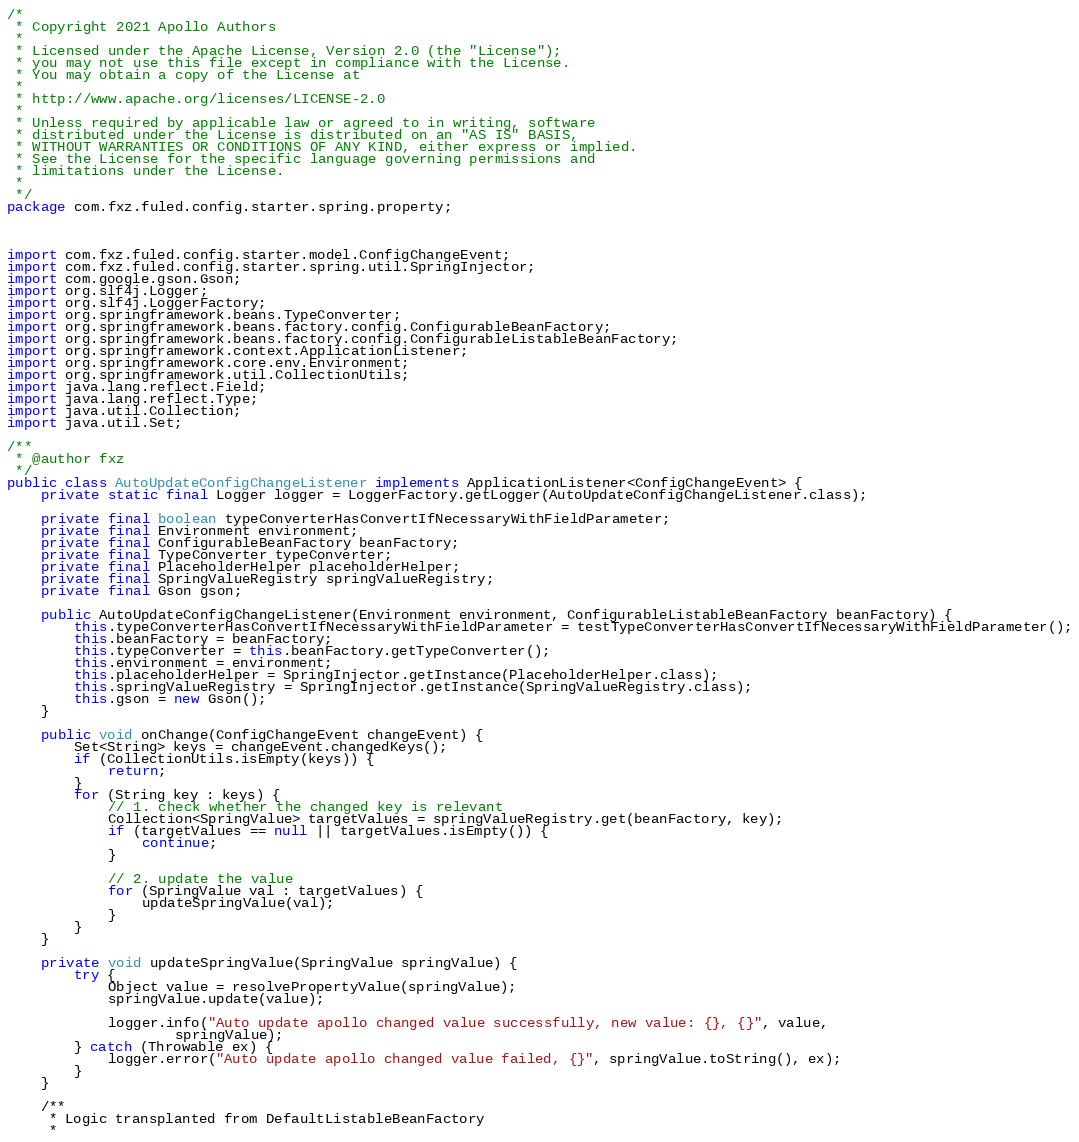<code> <loc_0><loc_0><loc_500><loc_500><_Java_>/*
 * Copyright 2021 Apollo Authors
 *
 * Licensed under the Apache License, Version 2.0 (the "License");
 * you may not use this file except in compliance with the License.
 * You may obtain a copy of the License at
 *
 * http://www.apache.org/licenses/LICENSE-2.0
 *
 * Unless required by applicable law or agreed to in writing, software
 * distributed under the License is distributed on an "AS IS" BASIS,
 * WITHOUT WARRANTIES OR CONDITIONS OF ANY KIND, either express or implied.
 * See the License for the specific language governing permissions and
 * limitations under the License.
 *
 */
package com.fxz.fuled.config.starter.spring.property;



import com.fxz.fuled.config.starter.model.ConfigChangeEvent;
import com.fxz.fuled.config.starter.spring.util.SpringInjector;
import com.google.gson.Gson;
import org.slf4j.Logger;
import org.slf4j.LoggerFactory;
import org.springframework.beans.TypeConverter;
import org.springframework.beans.factory.config.ConfigurableBeanFactory;
import org.springframework.beans.factory.config.ConfigurableListableBeanFactory;
import org.springframework.context.ApplicationListener;
import org.springframework.core.env.Environment;
import org.springframework.util.CollectionUtils;
import java.lang.reflect.Field;
import java.lang.reflect.Type;
import java.util.Collection;
import java.util.Set;

/**
 * @author fxz
 */
public class AutoUpdateConfigChangeListener implements ApplicationListener<ConfigChangeEvent> {
    private static final Logger logger = LoggerFactory.getLogger(AutoUpdateConfigChangeListener.class);

    private final boolean typeConverterHasConvertIfNecessaryWithFieldParameter;
    private final Environment environment;
    private final ConfigurableBeanFactory beanFactory;
    private final TypeConverter typeConverter;
    private final PlaceholderHelper placeholderHelper;
    private final SpringValueRegistry springValueRegistry;
    private final Gson gson;

    public AutoUpdateConfigChangeListener(Environment environment, ConfigurableListableBeanFactory beanFactory) {
        this.typeConverterHasConvertIfNecessaryWithFieldParameter = testTypeConverterHasConvertIfNecessaryWithFieldParameter();
        this.beanFactory = beanFactory;
        this.typeConverter = this.beanFactory.getTypeConverter();
        this.environment = environment;
        this.placeholderHelper = SpringInjector.getInstance(PlaceholderHelper.class);
        this.springValueRegistry = SpringInjector.getInstance(SpringValueRegistry.class);
        this.gson = new Gson();
    }

    public void onChange(ConfigChangeEvent changeEvent) {
        Set<String> keys = changeEvent.changedKeys();
        if (CollectionUtils.isEmpty(keys)) {
            return;
        }
        for (String key : keys) {
            // 1. check whether the changed key is relevant
            Collection<SpringValue> targetValues = springValueRegistry.get(beanFactory, key);
            if (targetValues == null || targetValues.isEmpty()) {
                continue;
            }

            // 2. update the value
            for (SpringValue val : targetValues) {
                updateSpringValue(val);
            }
        }
    }

    private void updateSpringValue(SpringValue springValue) {
        try {
            Object value = resolvePropertyValue(springValue);
            springValue.update(value);

            logger.info("Auto update apollo changed value successfully, new value: {}, {}", value,
                    springValue);
        } catch (Throwable ex) {
            logger.error("Auto update apollo changed value failed, {}", springValue.toString(), ex);
        }
    }

    /**
     * Logic transplanted from DefaultListableBeanFactory
     *</code> 